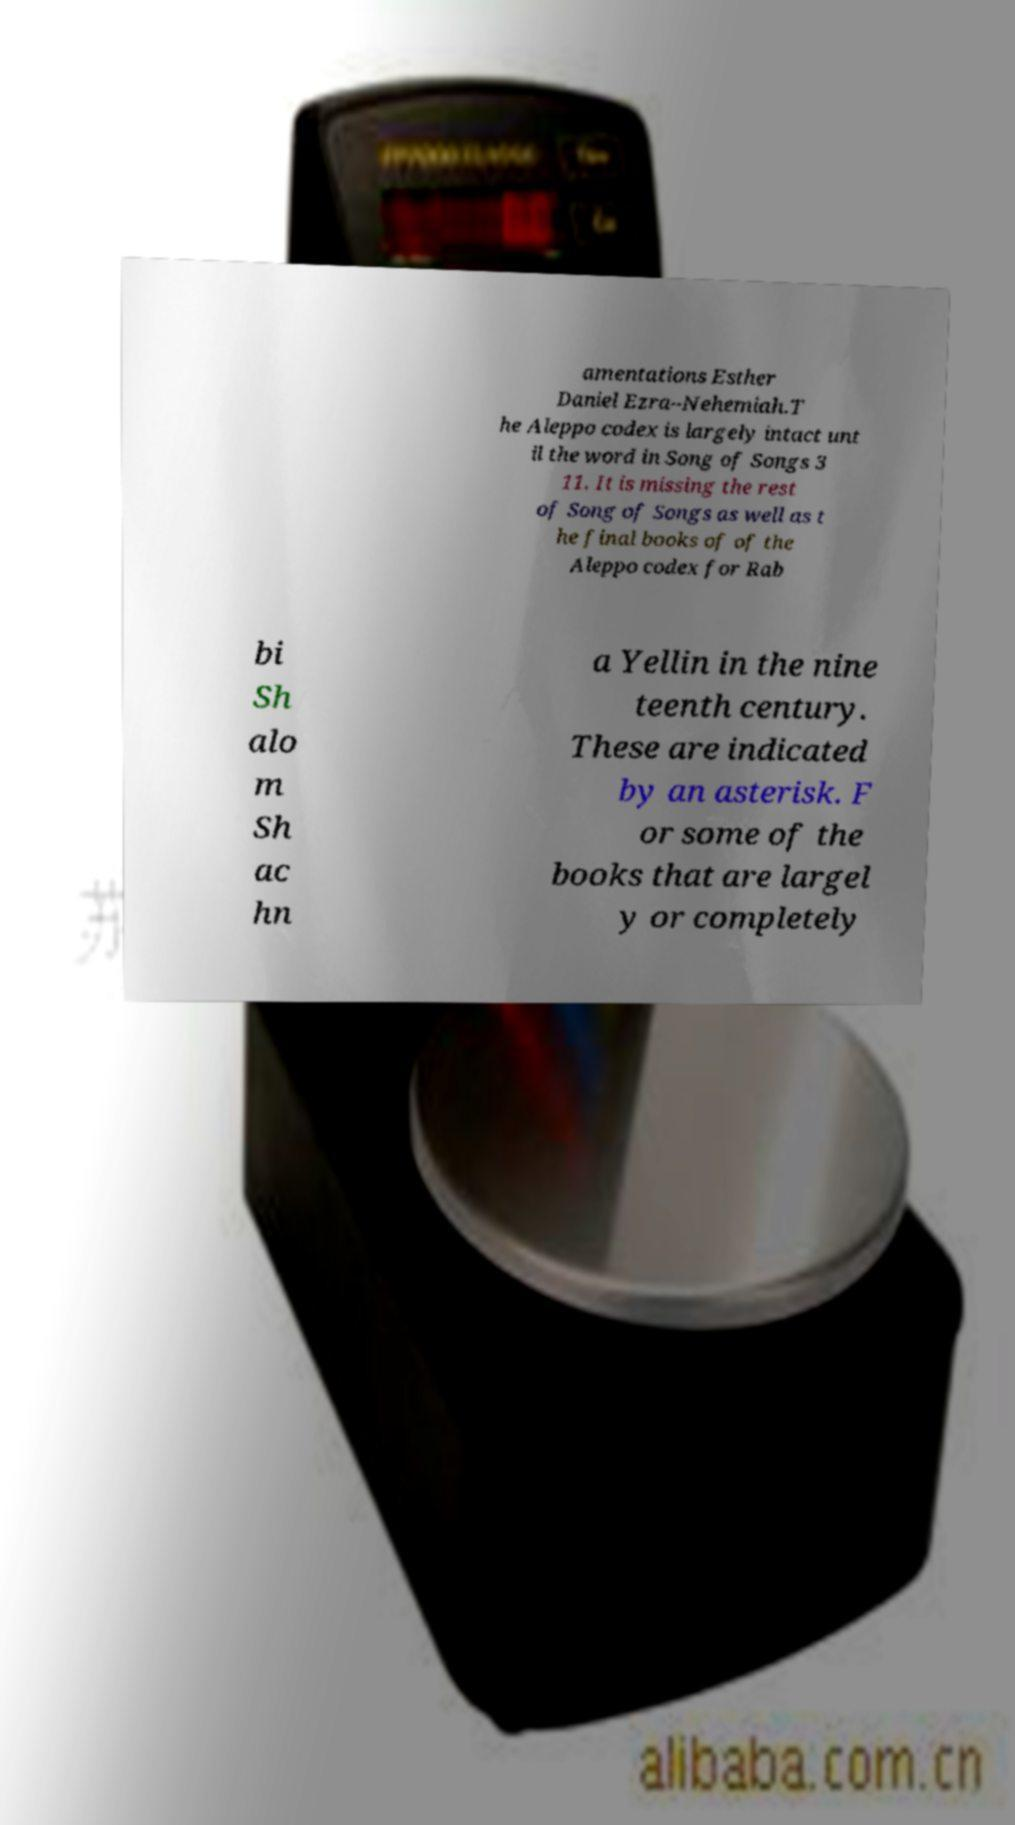Can you read and provide the text displayed in the image?This photo seems to have some interesting text. Can you extract and type it out for me? amentations Esther Daniel Ezra–Nehemiah.T he Aleppo codex is largely intact unt il the word in Song of Songs 3 11. It is missing the rest of Song of Songs as well as t he final books of of the Aleppo codex for Rab bi Sh alo m Sh ac hn a Yellin in the nine teenth century. These are indicated by an asterisk. F or some of the books that are largel y or completely 